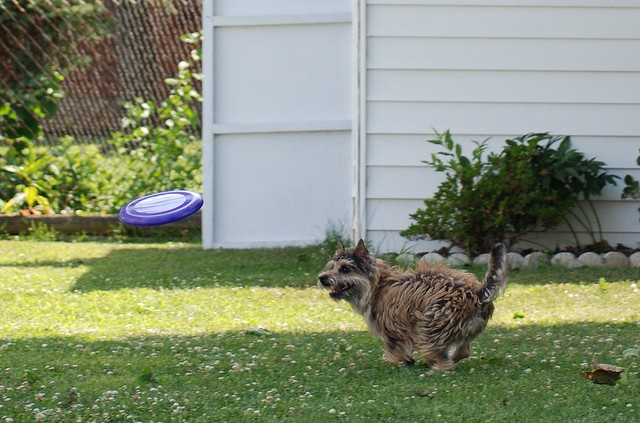Describe the objects in this image and their specific colors. I can see dog in olive, gray, and black tones and frisbee in olive, lavender, blue, darkgray, and navy tones in this image. 